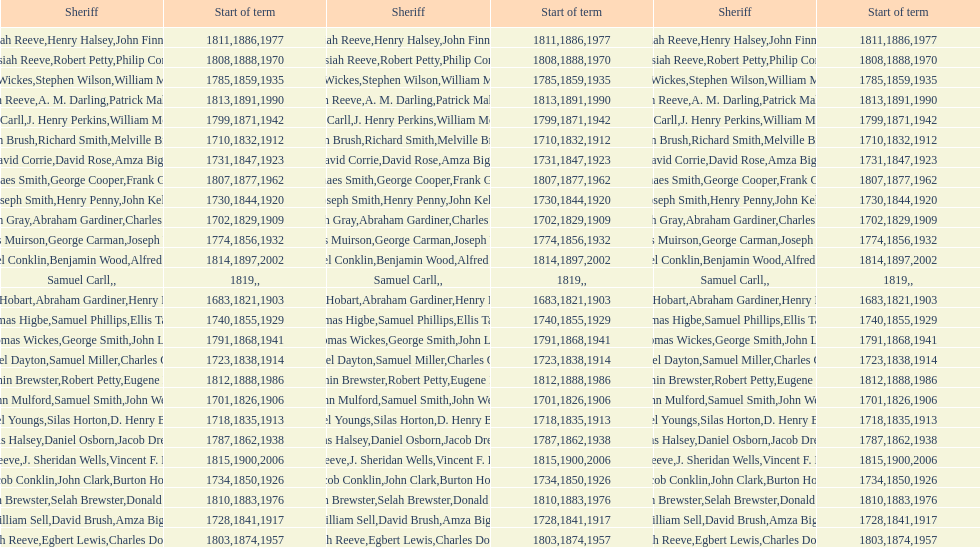What is the total number of sheriffs that were in office in suffolk county between 1903 and 1957? 17. Could you parse the entire table? {'header': ['Sheriff', 'Start of term', 'Sheriff', 'Start of term', 'Sheriff', 'Start of term'], 'rows': [['Josiah Reeve', '1811', 'Henry Halsey', '1886', 'John Finnerty', '1977'], ['Josiah Reeve', '1808', 'Robert Petty', '1888', 'Philip Corso', '1970'], ['Thomas Wickes', '1785', 'Stephen Wilson', '1859', 'William McCollom', '1935'], ['Josiah Reeve', '1813', 'A. M. Darling', '1891', 'Patrick Mahoney', '1990'], ['Phinaes Carll', '1799', 'J. Henry Perkins', '1871', 'William McCollom', '1942'], ['John Brush', '1710', 'Richard Smith', '1832', 'Melville Brush', '1912'], ['David Corrie', '1731', 'David Rose', '1847', 'Amza Biggs', '1923'], ['Phinaes Smith', '1807', 'George Cooper', '1877', 'Frank Gross', '1962'], ['Joseph Smith', '1730', 'Henry Penny', '1844', 'John Kelly', '1920'], ['Hugh Gray', '1702', 'Abraham Gardiner', '1829', 'Charles Platt', '1909'], ['James Muirson', '1774', 'George Carman', '1856', 'Joseph Warta', '1932'], ['Nathaniel Conklin', '1814', 'Benjamin Wood', '1897', 'Alfred C. Tisch', '2002'], ['Samuel Carll', '1819', '', '', '', ''], ['Josiah Hobart', '1683', 'Abraham Gardiner', '1821', 'Henry Preston', '1903'], ['Thomas Higbe', '1740', 'Samuel Phillips', '1855', 'Ellis Taylor', '1929'], ['Thomas Wickes', '1791', 'George Smith', '1868', 'John Levy', '1941'], ['Samuel Dayton', '1723', 'Samuel Miller', '1838', "Charles O'Dell", '1914'], ['Benjamin Brewster', '1812', 'Robert Petty', '1888', 'Eugene Dooley', '1986'], ['John Mulford', '1701', 'Samuel Smith', '1826', 'John Wells', '1906'], ['Daniel Youngs', '1718', 'Silas Horton', '1835', 'D. Henry Brown', '1913'], ['Silas Halsey', '1787', 'Daniel Osborn', '1862', 'Jacob Dreyer', '1938'], ['Josiah Reeve', '1815', 'J. Sheridan Wells', '1900', 'Vincent F. DeMarco', '2006'], ['Jacob Conklin', '1734', 'John Clark', '1850', 'Burton Howe', '1926'], ['Benjamin Brewster', '1810', 'Selah Brewster', '1883', 'Donald Dilworth', '1976'], ['William Sell', '1728', 'David Brush', '1841', 'Amza Biggs', '1917'], ['Josiah Reeve', '1803', 'Egbert Lewis', '1874', 'Charles Dominy', '1957']]} 